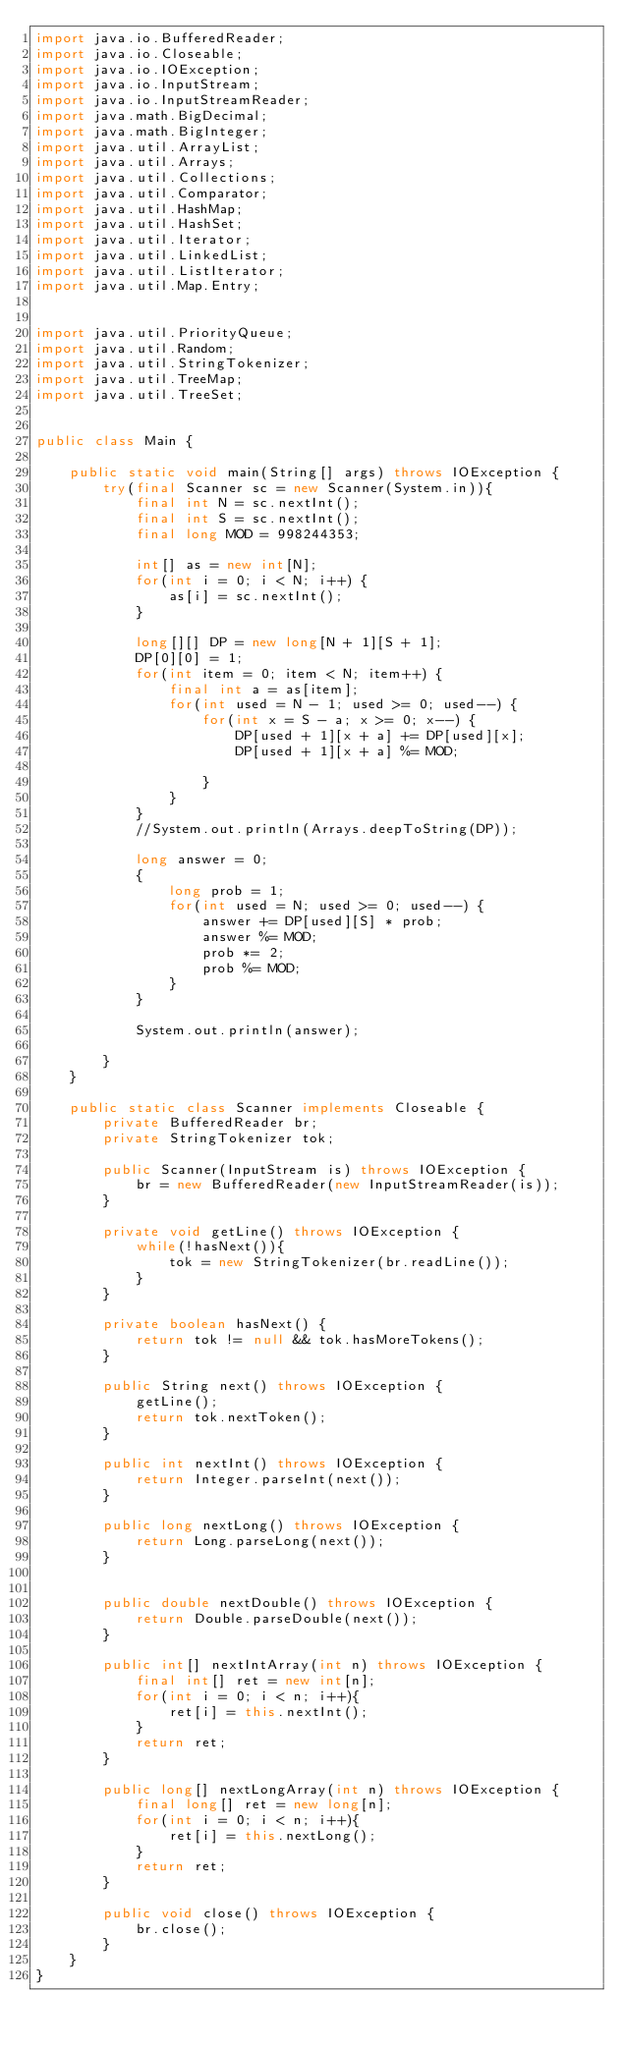<code> <loc_0><loc_0><loc_500><loc_500><_Java_>import java.io.BufferedReader;
import java.io.Closeable;
import java.io.IOException;
import java.io.InputStream;
import java.io.InputStreamReader;
import java.math.BigDecimal;
import java.math.BigInteger;
import java.util.ArrayList;
import java.util.Arrays;
import java.util.Collections;
import java.util.Comparator;
import java.util.HashMap;
import java.util.HashSet;
import java.util.Iterator;
import java.util.LinkedList;
import java.util.ListIterator;
import java.util.Map.Entry;


import java.util.PriorityQueue;
import java.util.Random;
import java.util.StringTokenizer;
import java.util.TreeMap;
import java.util.TreeSet;


public class Main {
	
	public static void main(String[] args) throws IOException {	
		try(final Scanner sc = new Scanner(System.in)){
			final int N = sc.nextInt();
			final int S = sc.nextInt();
			final long MOD = 998244353;
			
			int[] as = new int[N];
			for(int i = 0; i < N; i++) {
				as[i] = sc.nextInt();
			}
			
			long[][] DP = new long[N + 1][S + 1];
			DP[0][0] = 1;
			for(int item = 0; item < N; item++) {
				final int a = as[item];
				for(int used = N - 1; used >= 0; used--) {
					for(int x = S - a; x >= 0; x--) {
						DP[used + 1][x + a] += DP[used][x]; 
						DP[used + 1][x + a] %= MOD;
						
					}
				}
			}
			//System.out.println(Arrays.deepToString(DP));
			
			long answer = 0;
			{
				long prob = 1;
				for(int used = N; used >= 0; used--) {
					answer += DP[used][S] * prob;
					answer %= MOD;
					prob *= 2;
					prob %= MOD;
				}
			}
			
			System.out.println(answer);
			
		}
	}

	public static class Scanner implements Closeable {
		private BufferedReader br;
		private StringTokenizer tok;

		public Scanner(InputStream is) throws IOException {
			br = new BufferedReader(new InputStreamReader(is));
		}

		private void getLine() throws IOException {
			while(!hasNext()){
				tok = new StringTokenizer(br.readLine());
			}
		}

		private boolean hasNext() {
			return tok != null && tok.hasMoreTokens();
		}

		public String next() throws IOException {
			getLine();
			return tok.nextToken();
		}

		public int nextInt() throws IOException {
			return Integer.parseInt(next());
		}

		public long nextLong() throws IOException {
			return Long.parseLong(next());
		}
		

		public double nextDouble() throws IOException {
			return Double.parseDouble(next());
		}

		public int[] nextIntArray(int n) throws IOException {
			final int[] ret = new int[n];
			for(int i = 0; i < n; i++){
				ret[i] = this.nextInt();
			}
			return ret;
		}

		public long[] nextLongArray(int n) throws IOException {
			final long[] ret = new long[n];
			for(int i = 0; i < n; i++){
				ret[i] = this.nextLong();
			}
			return ret;
		}

		public void close() throws IOException {
			br.close();
		}
	}
}
</code> 